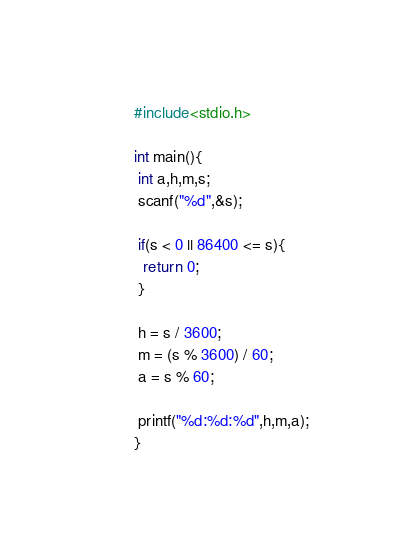Convert code to text. <code><loc_0><loc_0><loc_500><loc_500><_C_>#include<stdio.h>

int main(){
 int a,h,m,s;
 scanf("%d",&s);

 if(s < 0 || 86400 <= s){
  return 0;
 }
 
 h = s / 3600;
 m = (s % 3600) / 60;
 a = s % 60;

 printf("%d:%d:%d",h,m,a);
}
</code> 